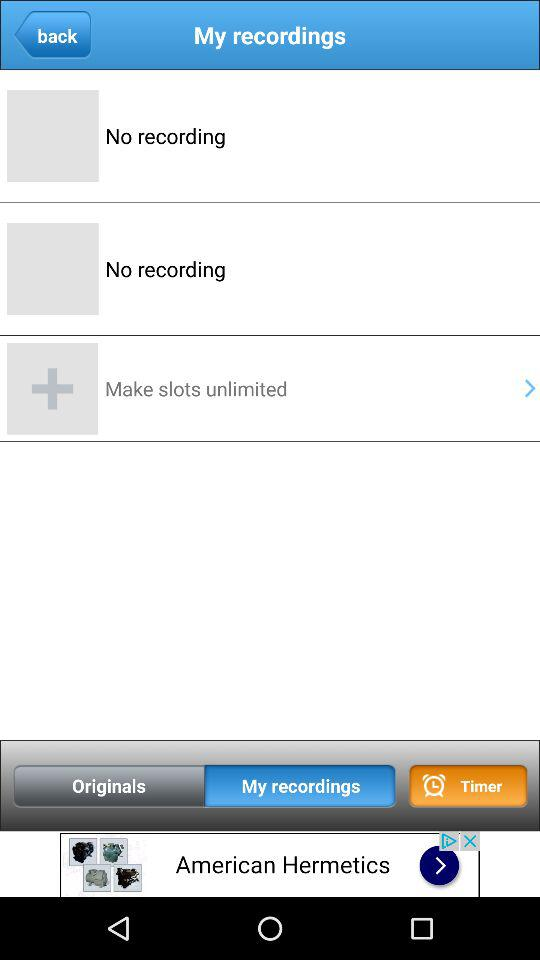Are there any recordings? There are no recordings. 